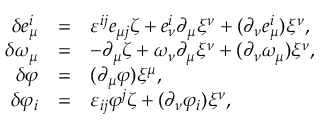Convert formula to latex. <formula><loc_0><loc_0><loc_500><loc_500>\begin{array} { r c l } { { \delta e _ { \mu } ^ { i } } } & { = } & { { \varepsilon ^ { i j } e _ { \mu j } \zeta + e _ { \nu } ^ { i } \partial _ { \mu } \xi ^ { \nu } + ( \partial _ { \nu } e _ { \mu } ^ { i } ) \xi ^ { \nu } , } } \\ { { \delta \omega _ { \mu } } } & { = } & { { - \partial _ { \mu } \zeta + \omega _ { \nu } \partial _ { \mu } \xi ^ { \nu } + ( \partial _ { \nu } \omega _ { \mu } ) \xi ^ { \nu } , } } \\ { \delta \varphi } & { = } & { { ( \partial _ { \mu } \varphi ) \xi ^ { \mu } , } } \\ { { \delta \varphi _ { i } } } & { = } & { { \varepsilon _ { i j } \varphi ^ { j } \zeta + ( \partial _ { \nu } \varphi _ { i } ) \xi ^ { \nu } , } } \end{array}</formula> 